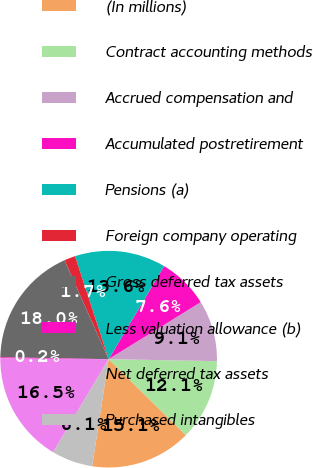Convert chart. <chart><loc_0><loc_0><loc_500><loc_500><pie_chart><fcel>(In millions)<fcel>Contract accounting methods<fcel>Accrued compensation and<fcel>Accumulated postretirement<fcel>Pensions (a)<fcel>Foreign company operating<fcel>Gross deferred tax assets<fcel>Less valuation allowance (b)<fcel>Net deferred tax assets<fcel>Purchased intangibles<nl><fcel>15.06%<fcel>12.09%<fcel>9.11%<fcel>7.62%<fcel>13.58%<fcel>1.66%<fcel>18.04%<fcel>0.17%<fcel>16.55%<fcel>6.13%<nl></chart> 